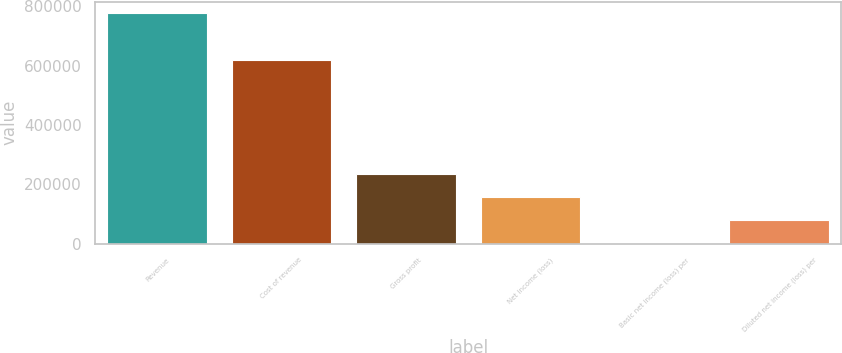Convert chart. <chart><loc_0><loc_0><loc_500><loc_500><bar_chart><fcel>Revenue<fcel>Cost of revenue<fcel>Gross profit<fcel>Net income (loss)<fcel>Basic net income (loss) per<fcel>Diluted net income (loss) per<nl><fcel>776520<fcel>619797<fcel>232956<fcel>155304<fcel>0.19<fcel>77652.2<nl></chart> 